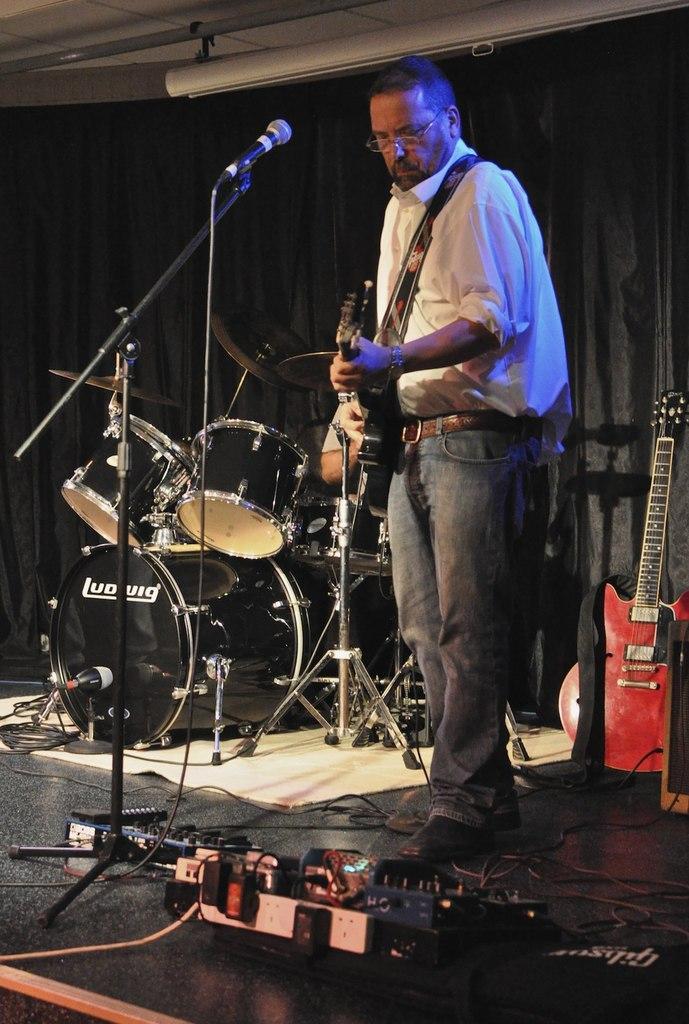In one or two sentences, can you explain what this image depicts? In this picture, there is a person towards the right and he is playing a guitar. Before him, there is a mike. At the bottom, there is a device. Beside him, there are drums. In the background there is a curtain and a guitar. 